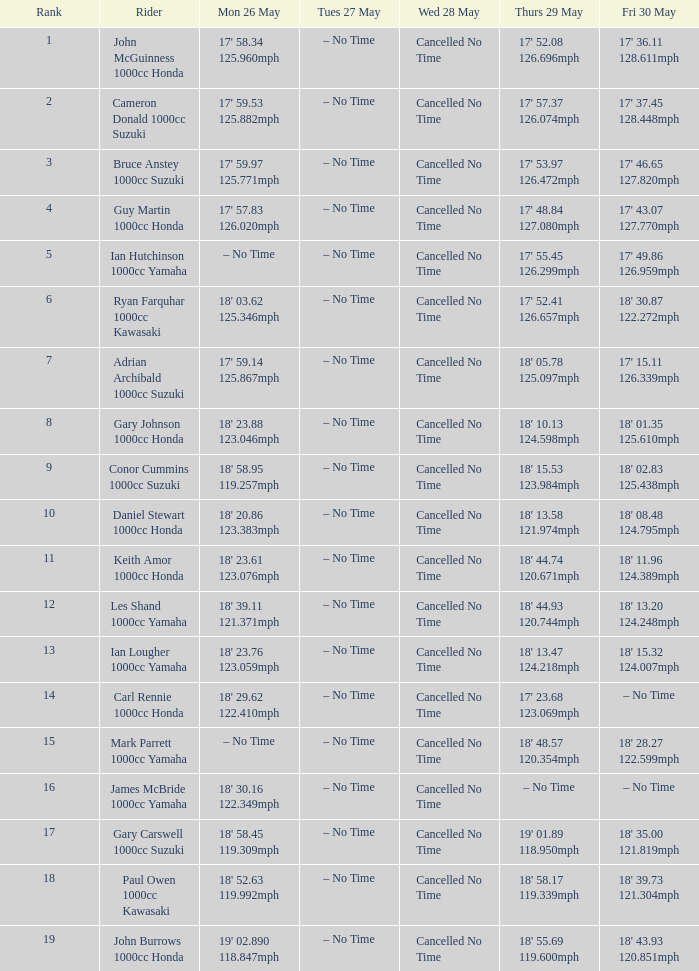When on may 28 (wednesday) and may 26 (monday) does the speed hit 17' 58.34 125.960mph? Cancelled No Time. 